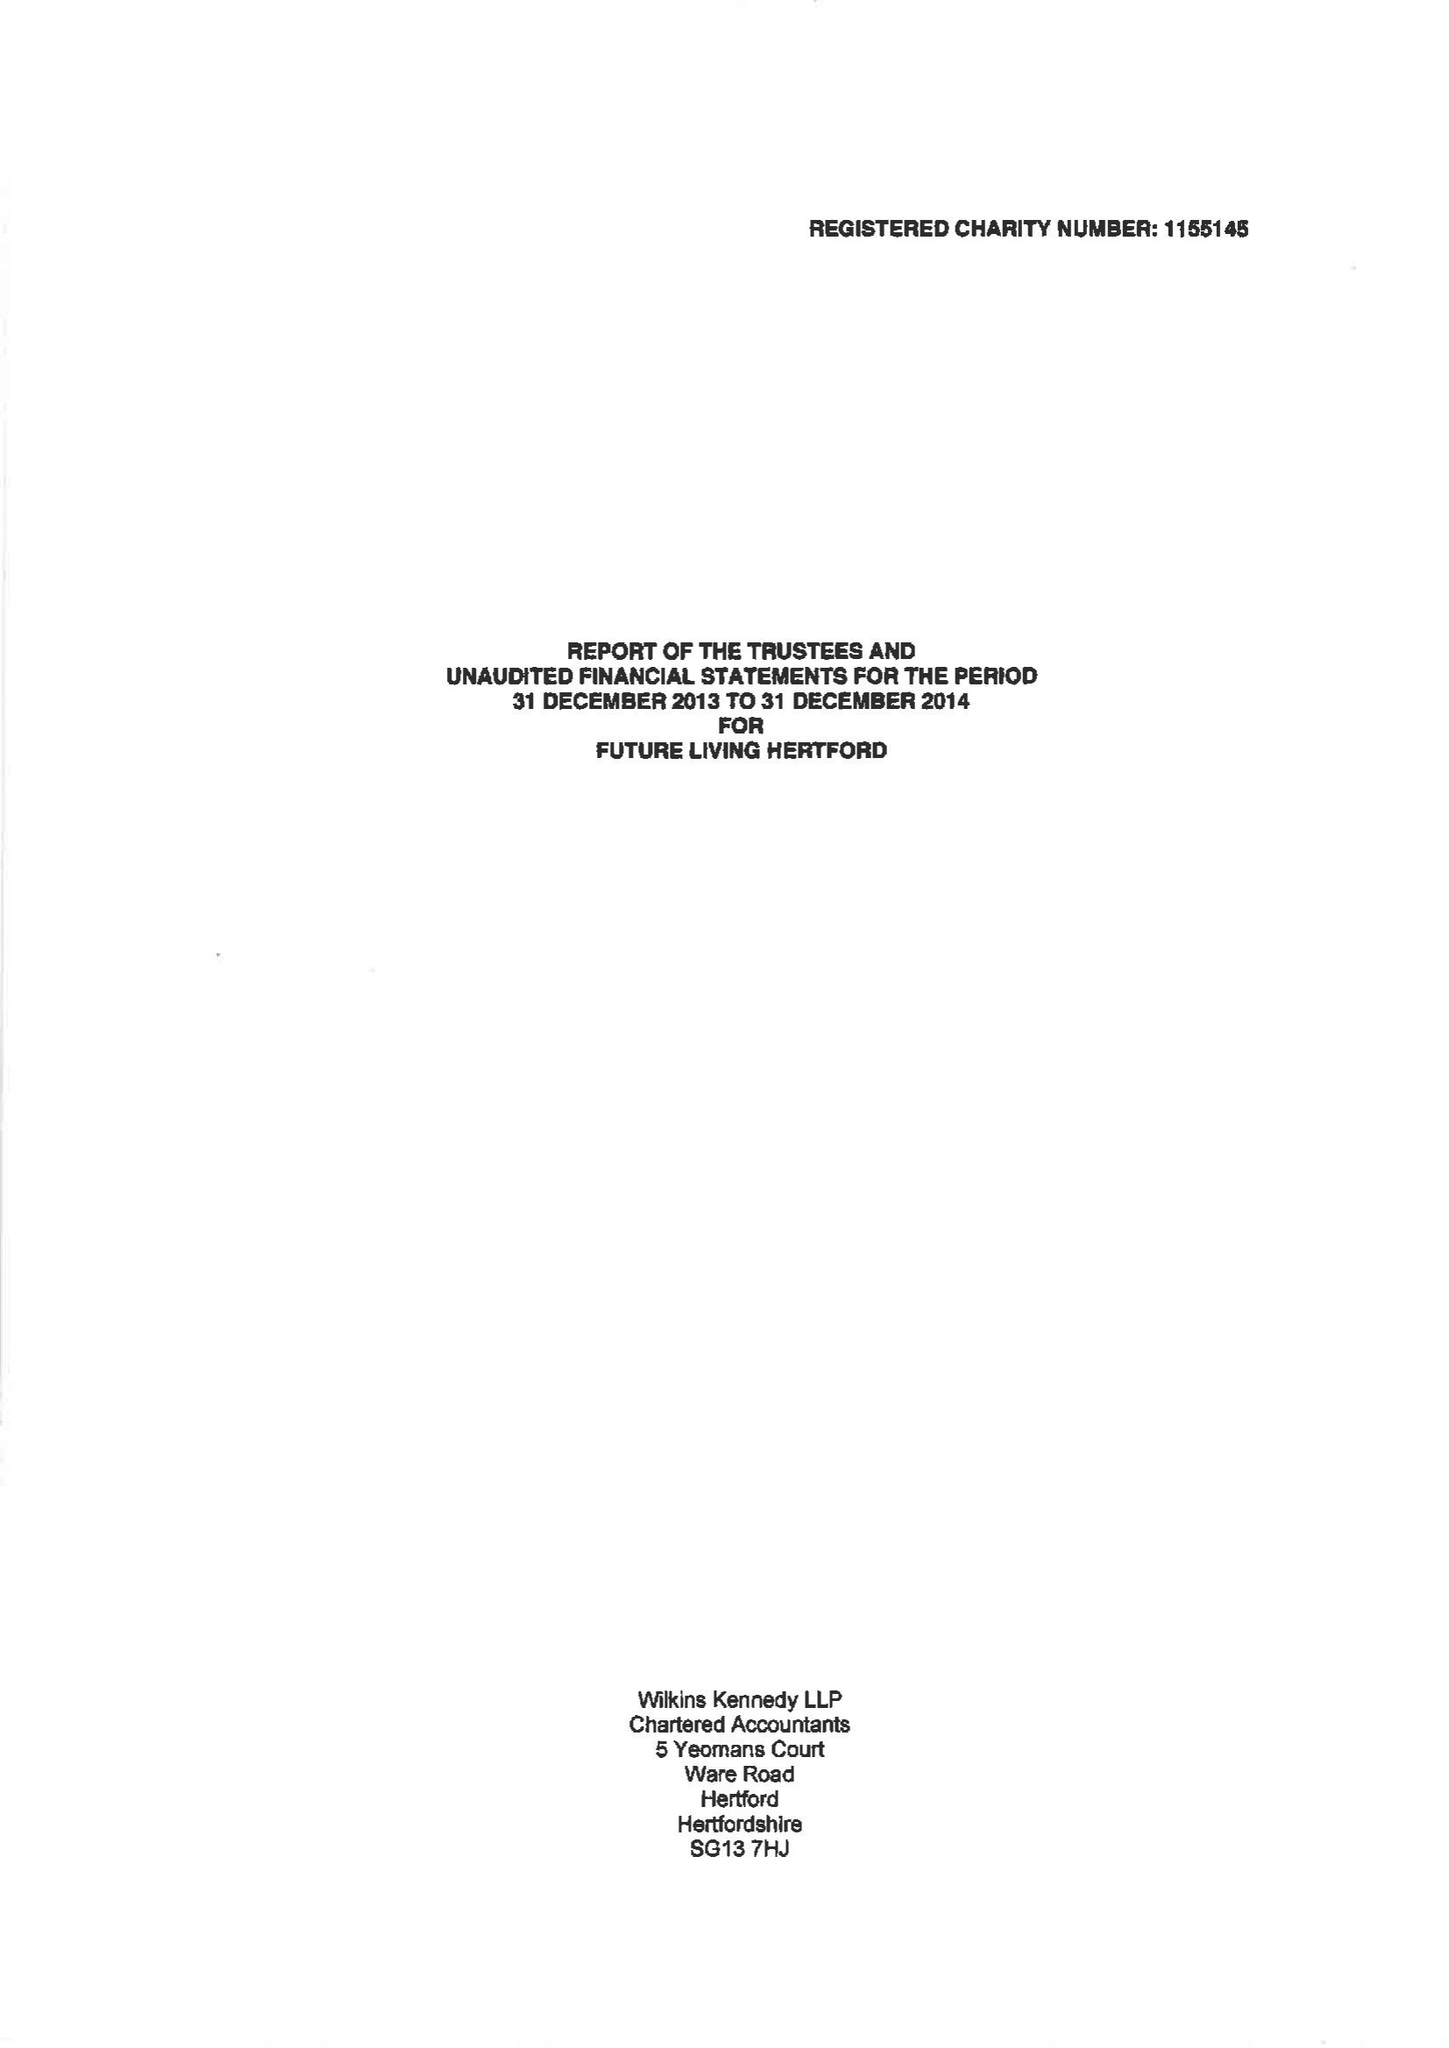What is the value for the income_annually_in_british_pounds?
Answer the question using a single word or phrase. 53698.00 